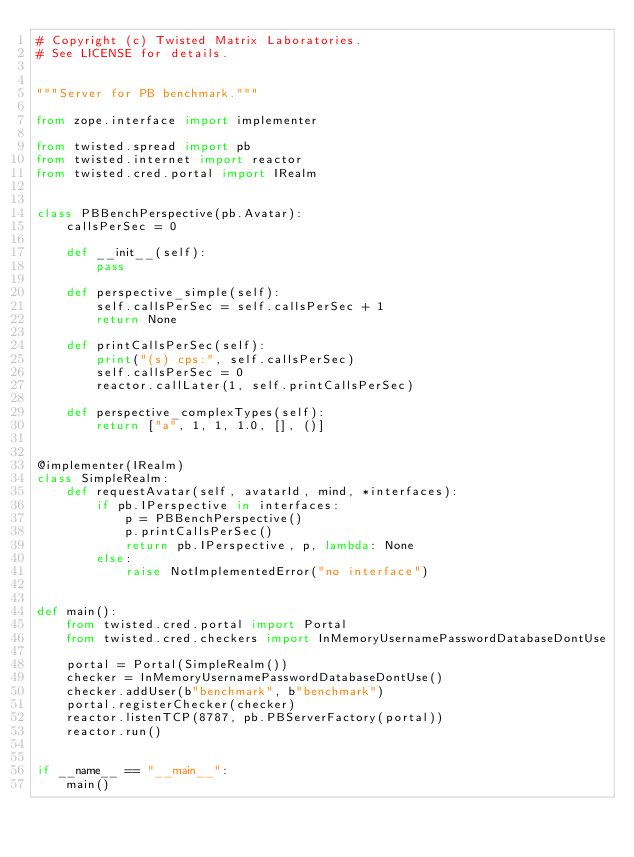Convert code to text. <code><loc_0><loc_0><loc_500><loc_500><_Python_># Copyright (c) Twisted Matrix Laboratories.
# See LICENSE for details.


"""Server for PB benchmark."""

from zope.interface import implementer

from twisted.spread import pb
from twisted.internet import reactor
from twisted.cred.portal import IRealm


class PBBenchPerspective(pb.Avatar):
    callsPerSec = 0

    def __init__(self):
        pass

    def perspective_simple(self):
        self.callsPerSec = self.callsPerSec + 1
        return None

    def printCallsPerSec(self):
        print("(s) cps:", self.callsPerSec)
        self.callsPerSec = 0
        reactor.callLater(1, self.printCallsPerSec)

    def perspective_complexTypes(self):
        return ["a", 1, 1, 1.0, [], ()]


@implementer(IRealm)
class SimpleRealm:
    def requestAvatar(self, avatarId, mind, *interfaces):
        if pb.IPerspective in interfaces:
            p = PBBenchPerspective()
            p.printCallsPerSec()
            return pb.IPerspective, p, lambda: None
        else:
            raise NotImplementedError("no interface")


def main():
    from twisted.cred.portal import Portal
    from twisted.cred.checkers import InMemoryUsernamePasswordDatabaseDontUse

    portal = Portal(SimpleRealm())
    checker = InMemoryUsernamePasswordDatabaseDontUse()
    checker.addUser(b"benchmark", b"benchmark")
    portal.registerChecker(checker)
    reactor.listenTCP(8787, pb.PBServerFactory(portal))
    reactor.run()


if __name__ == "__main__":
    main()
</code> 